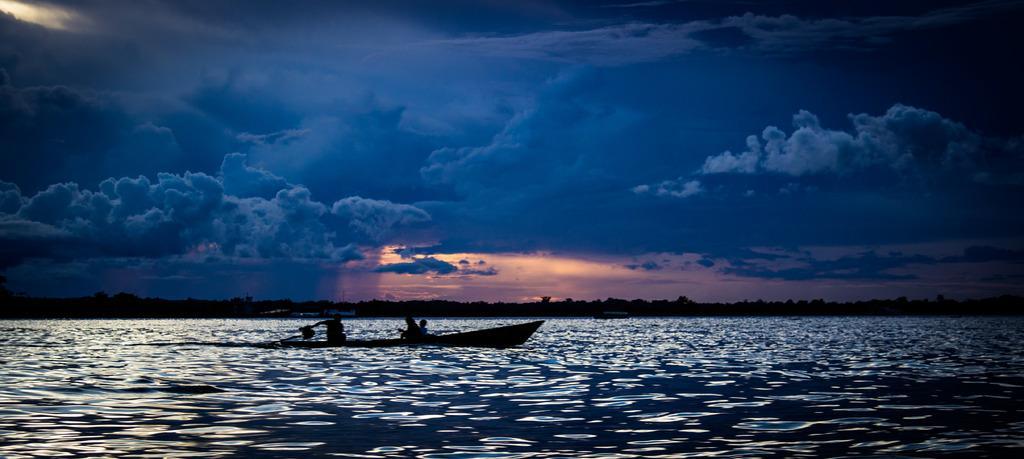How would you summarize this image in a sentence or two? This picture is clicked outside the city. In the foreground we can see a boat in the water body and we can see the group of persons in the boat. In the background we can see the sky which is full of clouds and we can see the trees and some other objects. 